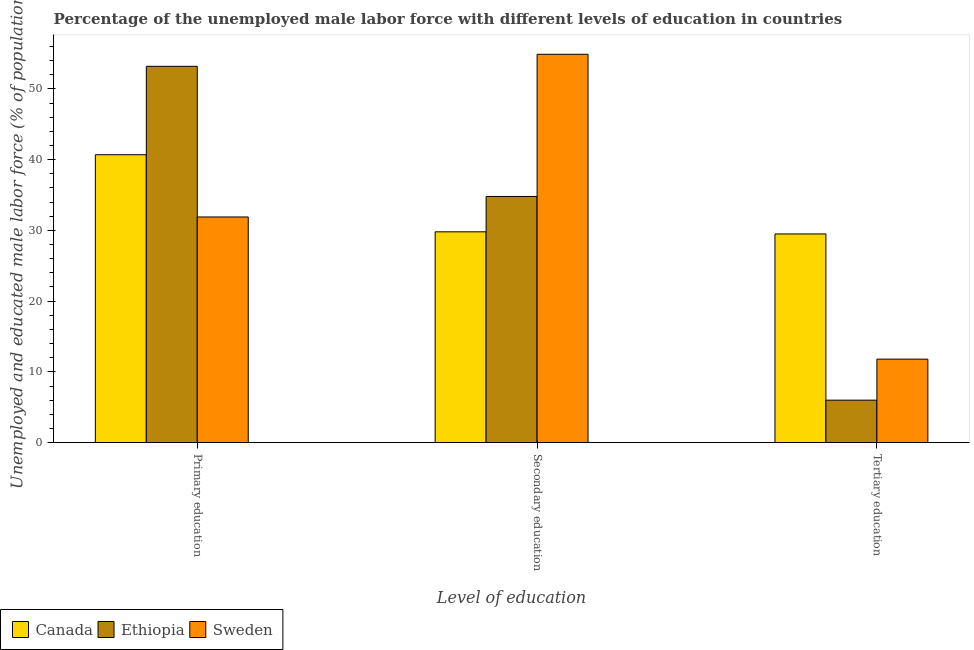How many different coloured bars are there?
Keep it short and to the point. 3. How many groups of bars are there?
Offer a very short reply. 3. What is the percentage of male labor force who received tertiary education in Canada?
Provide a short and direct response. 29.5. Across all countries, what is the maximum percentage of male labor force who received primary education?
Offer a terse response. 53.2. In which country was the percentage of male labor force who received primary education maximum?
Offer a very short reply. Ethiopia. What is the total percentage of male labor force who received primary education in the graph?
Keep it short and to the point. 125.8. What is the difference between the percentage of male labor force who received primary education in Ethiopia and that in Sweden?
Offer a terse response. 21.3. What is the difference between the percentage of male labor force who received tertiary education in Canada and the percentage of male labor force who received primary education in Ethiopia?
Your response must be concise. -23.7. What is the average percentage of male labor force who received secondary education per country?
Offer a terse response. 39.83. What is the difference between the percentage of male labor force who received secondary education and percentage of male labor force who received primary education in Ethiopia?
Give a very brief answer. -18.4. In how many countries, is the percentage of male labor force who received primary education greater than 36 %?
Offer a very short reply. 2. What is the ratio of the percentage of male labor force who received tertiary education in Canada to that in Ethiopia?
Your response must be concise. 4.92. Is the difference between the percentage of male labor force who received tertiary education in Ethiopia and Canada greater than the difference between the percentage of male labor force who received secondary education in Ethiopia and Canada?
Your answer should be very brief. No. What is the difference between the highest and the lowest percentage of male labor force who received secondary education?
Ensure brevity in your answer.  25.1. In how many countries, is the percentage of male labor force who received primary education greater than the average percentage of male labor force who received primary education taken over all countries?
Provide a short and direct response. 1. What does the 2nd bar from the left in Tertiary education represents?
Your answer should be very brief. Ethiopia. What does the 3rd bar from the right in Secondary education represents?
Keep it short and to the point. Canada. How many bars are there?
Make the answer very short. 9. How many countries are there in the graph?
Make the answer very short. 3. Does the graph contain any zero values?
Offer a terse response. No. Where does the legend appear in the graph?
Your answer should be very brief. Bottom left. How many legend labels are there?
Offer a terse response. 3. What is the title of the graph?
Your answer should be very brief. Percentage of the unemployed male labor force with different levels of education in countries. Does "Suriname" appear as one of the legend labels in the graph?
Ensure brevity in your answer.  No. What is the label or title of the X-axis?
Provide a short and direct response. Level of education. What is the label or title of the Y-axis?
Make the answer very short. Unemployed and educated male labor force (% of population). What is the Unemployed and educated male labor force (% of population) of Canada in Primary education?
Make the answer very short. 40.7. What is the Unemployed and educated male labor force (% of population) of Ethiopia in Primary education?
Provide a succinct answer. 53.2. What is the Unemployed and educated male labor force (% of population) of Sweden in Primary education?
Provide a short and direct response. 31.9. What is the Unemployed and educated male labor force (% of population) in Canada in Secondary education?
Give a very brief answer. 29.8. What is the Unemployed and educated male labor force (% of population) in Ethiopia in Secondary education?
Your answer should be very brief. 34.8. What is the Unemployed and educated male labor force (% of population) of Sweden in Secondary education?
Make the answer very short. 54.9. What is the Unemployed and educated male labor force (% of population) of Canada in Tertiary education?
Offer a very short reply. 29.5. What is the Unemployed and educated male labor force (% of population) of Sweden in Tertiary education?
Your answer should be compact. 11.8. Across all Level of education, what is the maximum Unemployed and educated male labor force (% of population) in Canada?
Ensure brevity in your answer.  40.7. Across all Level of education, what is the maximum Unemployed and educated male labor force (% of population) in Ethiopia?
Keep it short and to the point. 53.2. Across all Level of education, what is the maximum Unemployed and educated male labor force (% of population) of Sweden?
Your answer should be compact. 54.9. Across all Level of education, what is the minimum Unemployed and educated male labor force (% of population) of Canada?
Your answer should be compact. 29.5. Across all Level of education, what is the minimum Unemployed and educated male labor force (% of population) of Ethiopia?
Your response must be concise. 6. Across all Level of education, what is the minimum Unemployed and educated male labor force (% of population) in Sweden?
Provide a short and direct response. 11.8. What is the total Unemployed and educated male labor force (% of population) in Ethiopia in the graph?
Provide a succinct answer. 94. What is the total Unemployed and educated male labor force (% of population) of Sweden in the graph?
Your answer should be very brief. 98.6. What is the difference between the Unemployed and educated male labor force (% of population) in Sweden in Primary education and that in Secondary education?
Ensure brevity in your answer.  -23. What is the difference between the Unemployed and educated male labor force (% of population) of Ethiopia in Primary education and that in Tertiary education?
Your answer should be compact. 47.2. What is the difference between the Unemployed and educated male labor force (% of population) of Sweden in Primary education and that in Tertiary education?
Provide a short and direct response. 20.1. What is the difference between the Unemployed and educated male labor force (% of population) in Canada in Secondary education and that in Tertiary education?
Provide a succinct answer. 0.3. What is the difference between the Unemployed and educated male labor force (% of population) in Ethiopia in Secondary education and that in Tertiary education?
Keep it short and to the point. 28.8. What is the difference between the Unemployed and educated male labor force (% of population) in Sweden in Secondary education and that in Tertiary education?
Offer a very short reply. 43.1. What is the difference between the Unemployed and educated male labor force (% of population) in Canada in Primary education and the Unemployed and educated male labor force (% of population) in Sweden in Secondary education?
Ensure brevity in your answer.  -14.2. What is the difference between the Unemployed and educated male labor force (% of population) of Canada in Primary education and the Unemployed and educated male labor force (% of population) of Ethiopia in Tertiary education?
Ensure brevity in your answer.  34.7. What is the difference between the Unemployed and educated male labor force (% of population) in Canada in Primary education and the Unemployed and educated male labor force (% of population) in Sweden in Tertiary education?
Provide a succinct answer. 28.9. What is the difference between the Unemployed and educated male labor force (% of population) of Ethiopia in Primary education and the Unemployed and educated male labor force (% of population) of Sweden in Tertiary education?
Make the answer very short. 41.4. What is the difference between the Unemployed and educated male labor force (% of population) of Canada in Secondary education and the Unemployed and educated male labor force (% of population) of Ethiopia in Tertiary education?
Keep it short and to the point. 23.8. What is the average Unemployed and educated male labor force (% of population) in Canada per Level of education?
Give a very brief answer. 33.33. What is the average Unemployed and educated male labor force (% of population) of Ethiopia per Level of education?
Give a very brief answer. 31.33. What is the average Unemployed and educated male labor force (% of population) of Sweden per Level of education?
Give a very brief answer. 32.87. What is the difference between the Unemployed and educated male labor force (% of population) in Canada and Unemployed and educated male labor force (% of population) in Sweden in Primary education?
Ensure brevity in your answer.  8.8. What is the difference between the Unemployed and educated male labor force (% of population) in Ethiopia and Unemployed and educated male labor force (% of population) in Sweden in Primary education?
Give a very brief answer. 21.3. What is the difference between the Unemployed and educated male labor force (% of population) in Canada and Unemployed and educated male labor force (% of population) in Sweden in Secondary education?
Give a very brief answer. -25.1. What is the difference between the Unemployed and educated male labor force (% of population) of Ethiopia and Unemployed and educated male labor force (% of population) of Sweden in Secondary education?
Keep it short and to the point. -20.1. What is the difference between the Unemployed and educated male labor force (% of population) in Canada and Unemployed and educated male labor force (% of population) in Ethiopia in Tertiary education?
Offer a terse response. 23.5. What is the difference between the Unemployed and educated male labor force (% of population) in Canada and Unemployed and educated male labor force (% of population) in Sweden in Tertiary education?
Keep it short and to the point. 17.7. What is the ratio of the Unemployed and educated male labor force (% of population) of Canada in Primary education to that in Secondary education?
Offer a very short reply. 1.37. What is the ratio of the Unemployed and educated male labor force (% of population) of Ethiopia in Primary education to that in Secondary education?
Your answer should be compact. 1.53. What is the ratio of the Unemployed and educated male labor force (% of population) in Sweden in Primary education to that in Secondary education?
Your response must be concise. 0.58. What is the ratio of the Unemployed and educated male labor force (% of population) of Canada in Primary education to that in Tertiary education?
Give a very brief answer. 1.38. What is the ratio of the Unemployed and educated male labor force (% of population) in Ethiopia in Primary education to that in Tertiary education?
Provide a succinct answer. 8.87. What is the ratio of the Unemployed and educated male labor force (% of population) in Sweden in Primary education to that in Tertiary education?
Ensure brevity in your answer.  2.7. What is the ratio of the Unemployed and educated male labor force (% of population) in Canada in Secondary education to that in Tertiary education?
Ensure brevity in your answer.  1.01. What is the ratio of the Unemployed and educated male labor force (% of population) of Sweden in Secondary education to that in Tertiary education?
Keep it short and to the point. 4.65. What is the difference between the highest and the second highest Unemployed and educated male labor force (% of population) in Canada?
Your response must be concise. 10.9. What is the difference between the highest and the second highest Unemployed and educated male labor force (% of population) in Ethiopia?
Your answer should be compact. 18.4. What is the difference between the highest and the second highest Unemployed and educated male labor force (% of population) of Sweden?
Provide a succinct answer. 23. What is the difference between the highest and the lowest Unemployed and educated male labor force (% of population) of Ethiopia?
Your answer should be compact. 47.2. What is the difference between the highest and the lowest Unemployed and educated male labor force (% of population) in Sweden?
Ensure brevity in your answer.  43.1. 